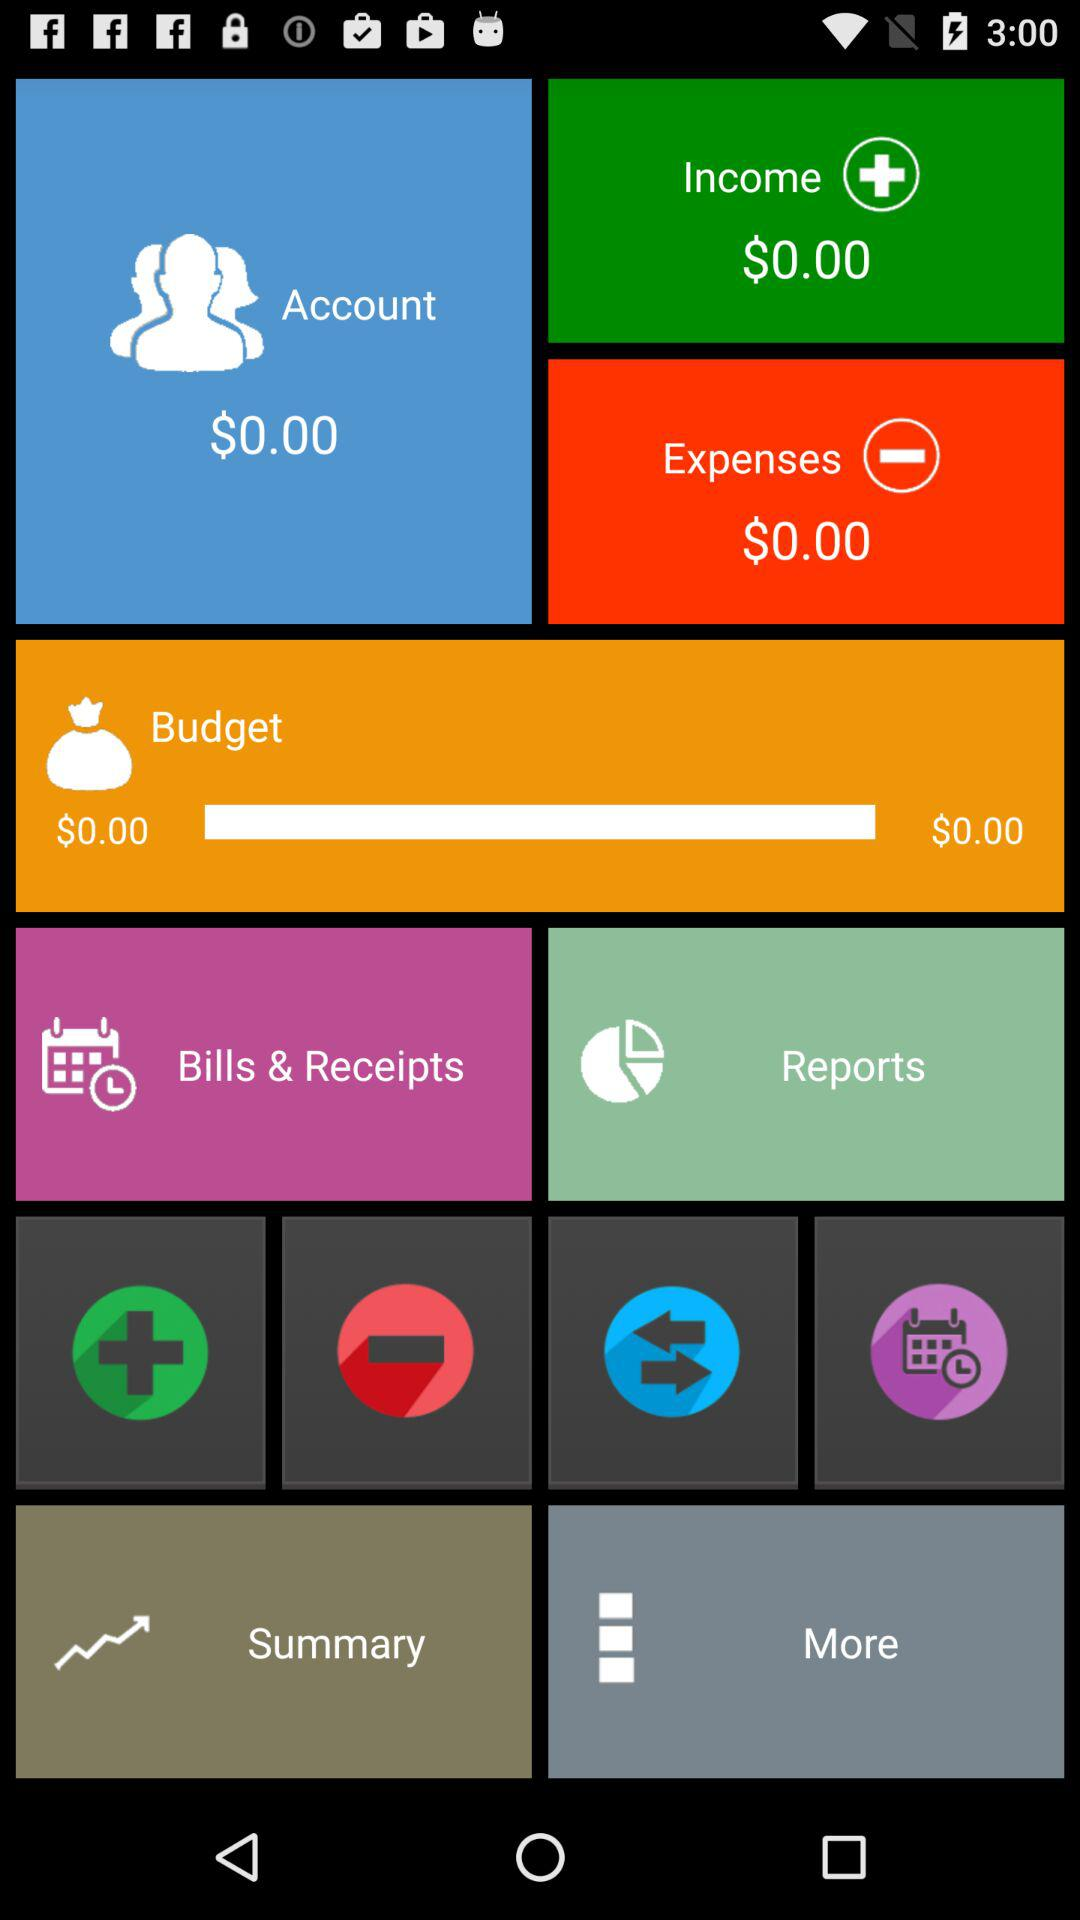What is the total balance in the account? The total balance is $0. 